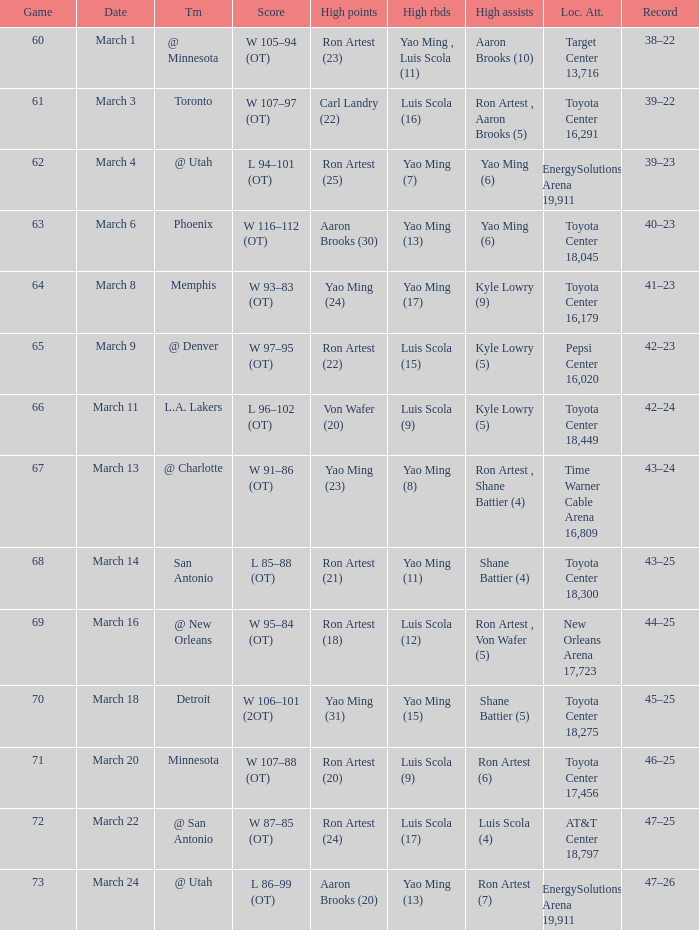Who had the most poinst in game 72? Ron Artest (24). 